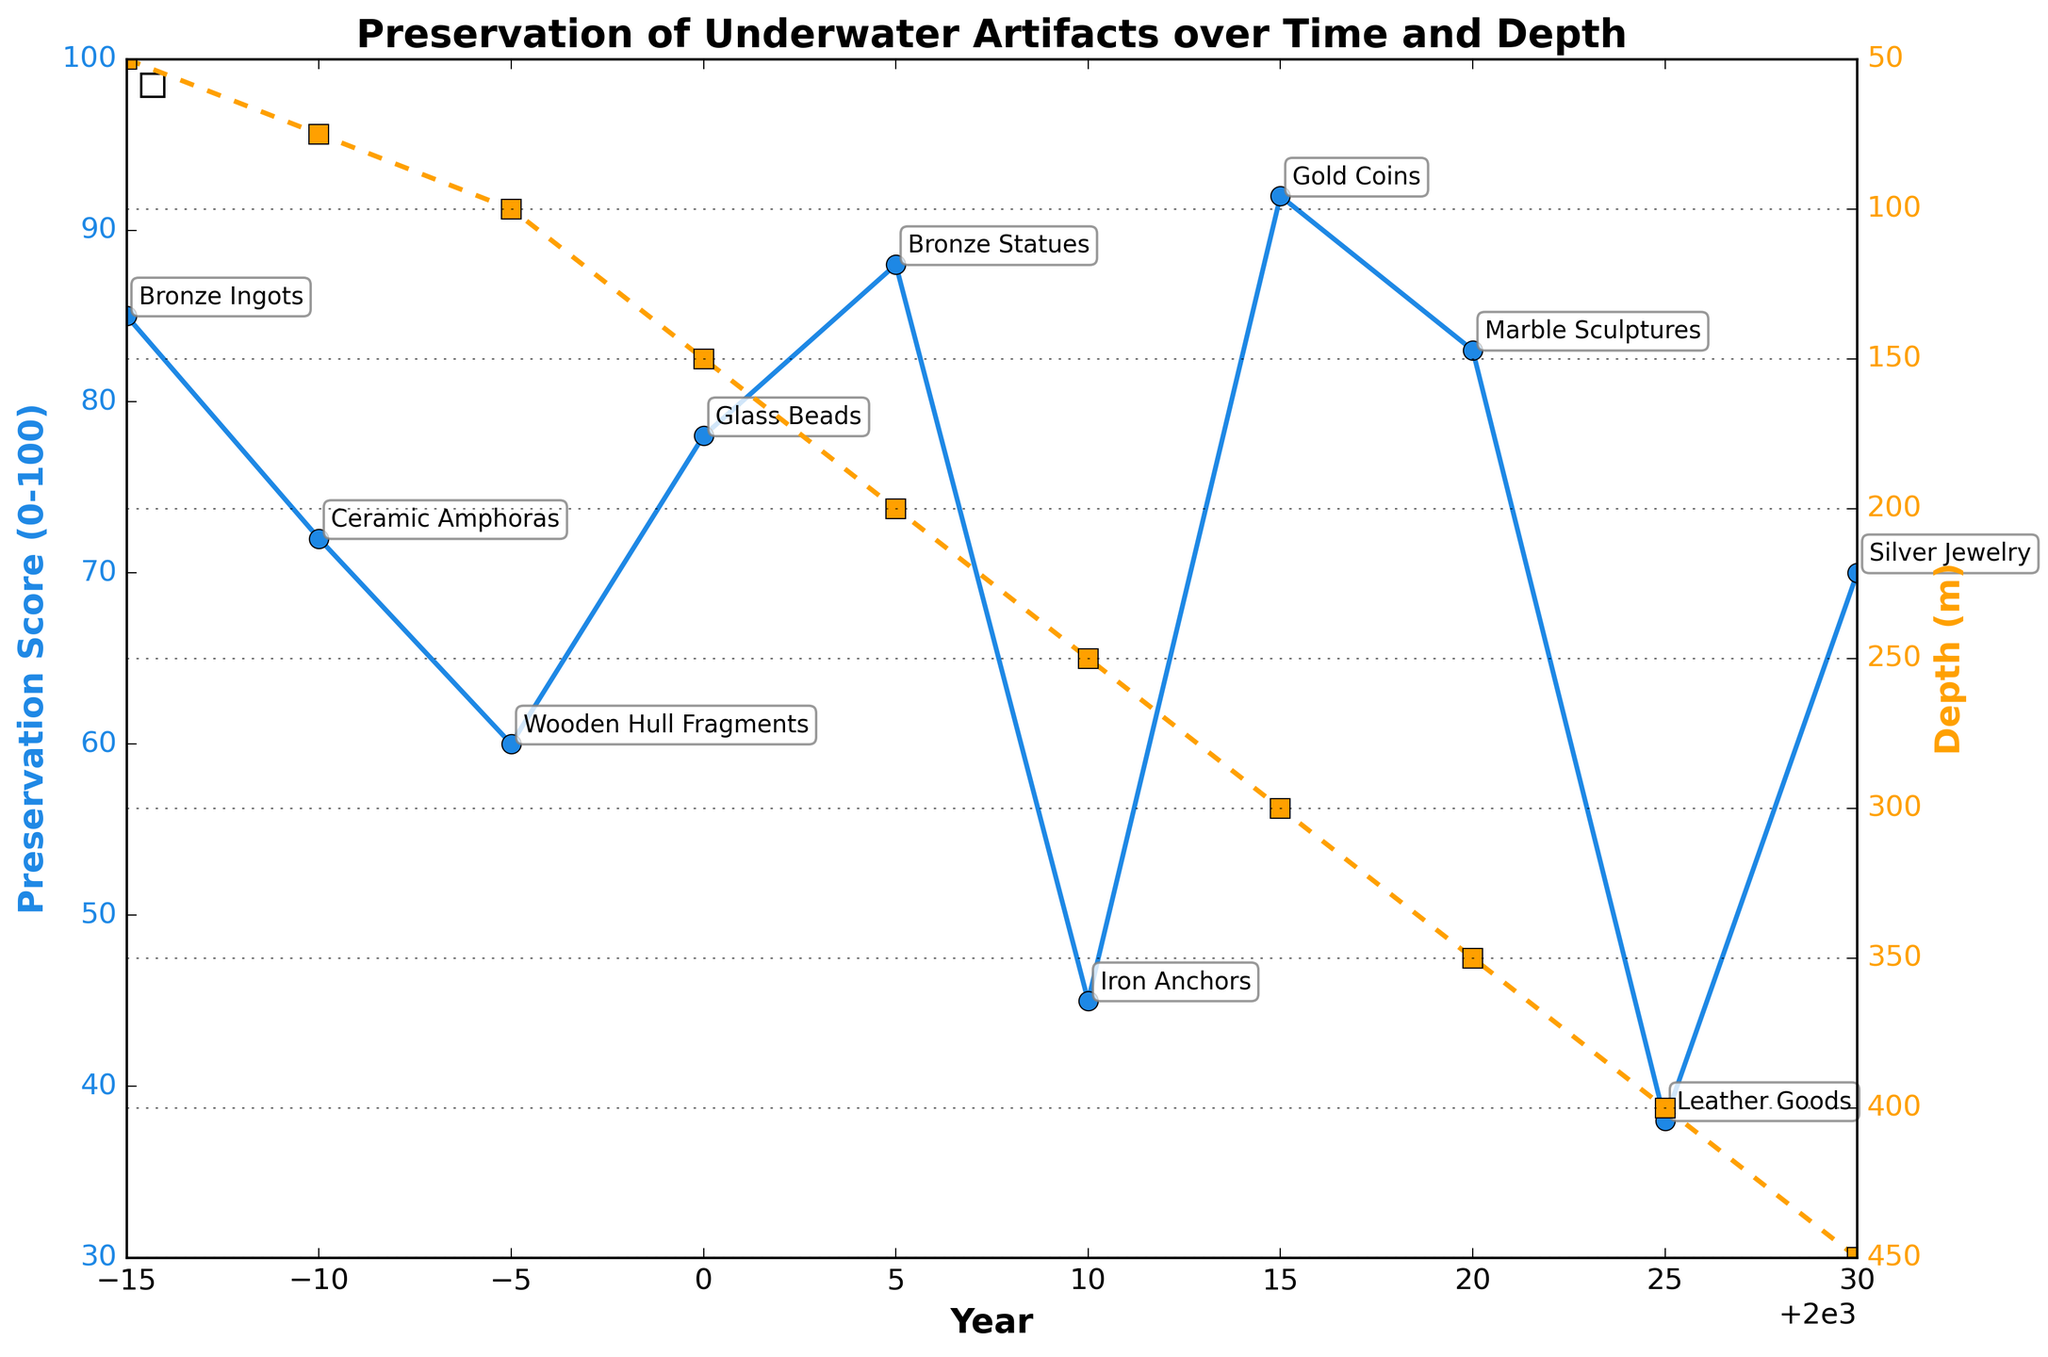What trend is observed in the preservation score from 1985 to 2030? The preservation score shows a general pattern of fluctuation. It starts high in 1985 at 85, then decreases in 1990, increases in 2005, decreases again in 2010, peaks in 2015, and finally drops noticeably by 2025.
Answer: Fluctuating Does depth have any visible correlation with preservation scores over the years? As depth increases, there are fluctuations in the preservation score without a clear upward or downward overall trend. For example, in 2005 the score is 88 at 200 meters depth, but in 2025 the score is only 38 at the greater depth of 400 meters.
Answer: No clear trend Which artifact type had the highest preservation score? By looking at the annotations and preservation scores, the gold coins from the Methone Shipwreck in 2015 had the highest preservation score at 92.
Answer: Gold Coins When was the preservation score the lowest? The lowest preservation score is observed in 2025, with a score of 38 for the Leather Goods from the Yassi Ada Wreck.
Answer: 2025 Compare the preservation score of the Bronze Ingots in 1985 to that of the Silver Jewelry in 2030. Which one is higher and by how much? The preservation score of the Bronze Ingots in 1985 is 85, and the score for the Silver Jewelry in 2030 is 70. The Bronze Ingots have a higher score by 15 points.
Answer: Bronze Ingots by 15 points What is the difference in depth between the deepest and shallowest shipwrecks? The deepest shipwreck is at 450 meters (Porticello Shipwreck in 2030) and the shallowest is at 50 meters (Uluburun Shipwreck in 1985). The difference in depth is 450 - 50 = 400 meters.
Answer: 400 meters Which years saw an increase in preservation score compared to the previous recorded year? The years 1995, 2005, 2015, and 2020 saw increases in preservation scores compared to the previous years (1990, 2000, 2010, and 2015 respectively).
Answer: 1995, 2005, 2015, 2020 What visual patterns indicate the correlation between depth and preservation? The chart uses lines with different colors for preservation score (blue) and depth (orange). While reading the chart, you can observe how changes in one correspond to changes in another visually. For instance, despite increasing depth from 2010 to 2015, the preservation score increases, showing no simple direct influence.
Answer: Color-coded lines with different trends Between which years did the preservation score see the steepest decline? Analyzing the line plot, the steepest decline in preservation score occurs between 2015 and 2025, where the score drops from 92 to 38.
Answer: 2015 to 2025 